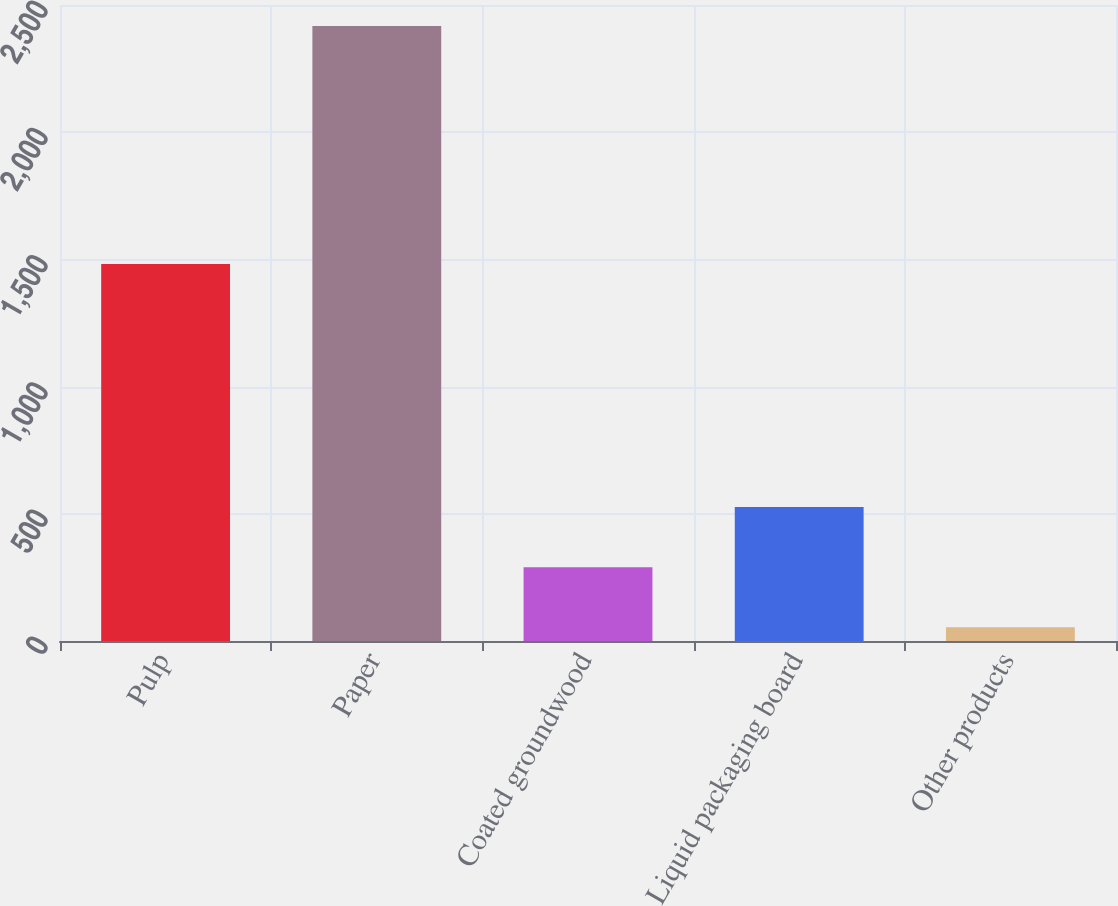<chart> <loc_0><loc_0><loc_500><loc_500><bar_chart><fcel>Pulp<fcel>Paper<fcel>Coated groundwood<fcel>Liquid packaging board<fcel>Other products<nl><fcel>1482<fcel>2417<fcel>290.3<fcel>526.6<fcel>54<nl></chart> 